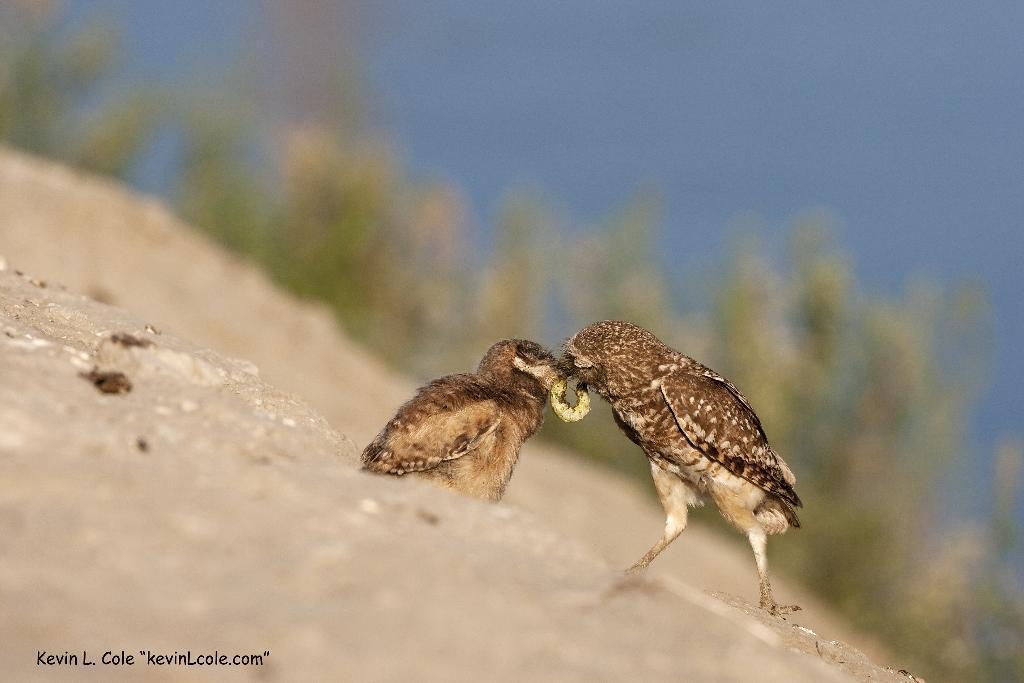How would you summarize this image in a sentence or two? In the center of the image, we can see birds eating and insect. In the background, there are trees. At the bottom, there is wood and we can see some text. 